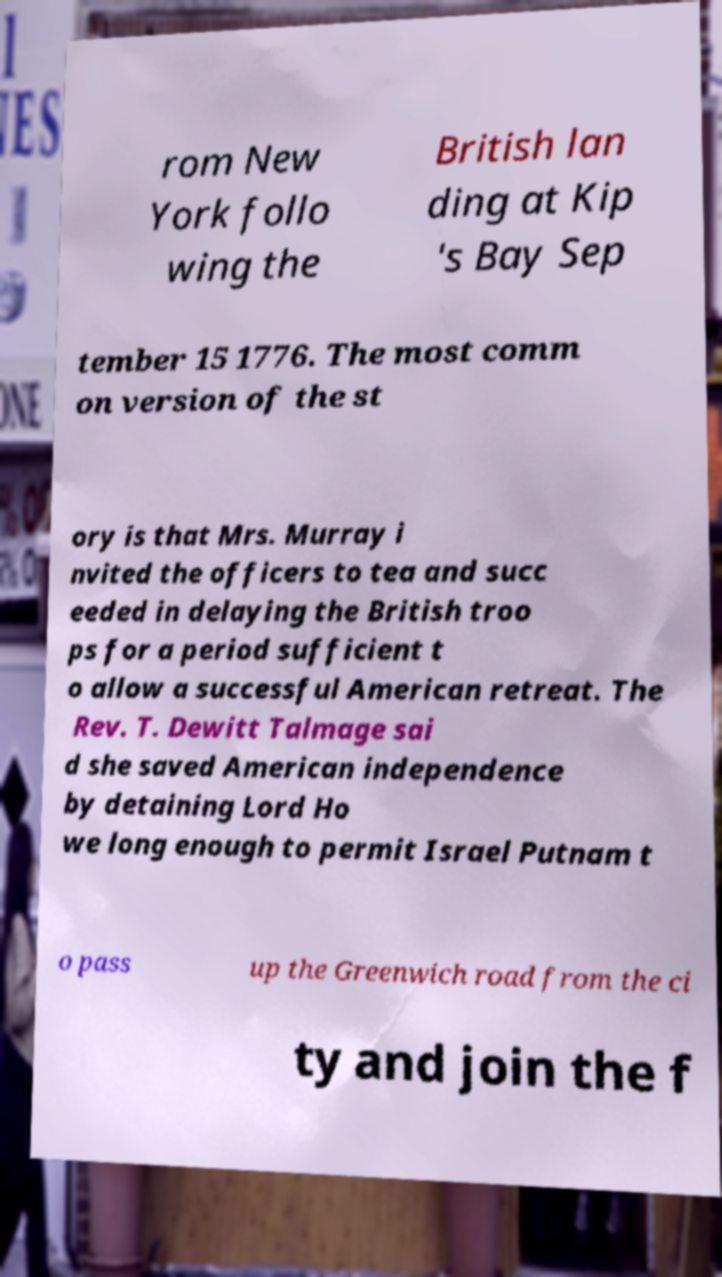For documentation purposes, I need the text within this image transcribed. Could you provide that? rom New York follo wing the British lan ding at Kip 's Bay Sep tember 15 1776. The most comm on version of the st ory is that Mrs. Murray i nvited the officers to tea and succ eeded in delaying the British troo ps for a period sufficient t o allow a successful American retreat. The Rev. T. Dewitt Talmage sai d she saved American independence by detaining Lord Ho we long enough to permit Israel Putnam t o pass up the Greenwich road from the ci ty and join the f 